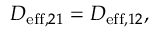<formula> <loc_0><loc_0><loc_500><loc_500>\begin{array} { r } { D _ { e f f , 2 1 } = D _ { e f f , 1 2 } , } \end{array}</formula> 